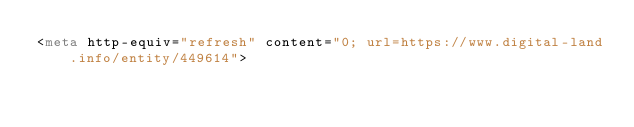Convert code to text. <code><loc_0><loc_0><loc_500><loc_500><_HTML_><meta http-equiv="refresh" content="0; url=https://www.digital-land.info/entity/449614"></code> 